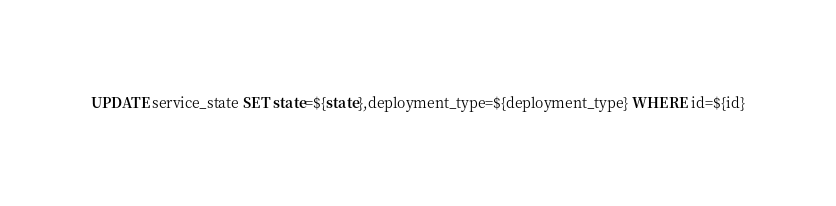Convert code to text. <code><loc_0><loc_0><loc_500><loc_500><_SQL_>UPDATE service_state SET state=${state},deployment_type=${deployment_type} WHERE id=${id}
</code> 